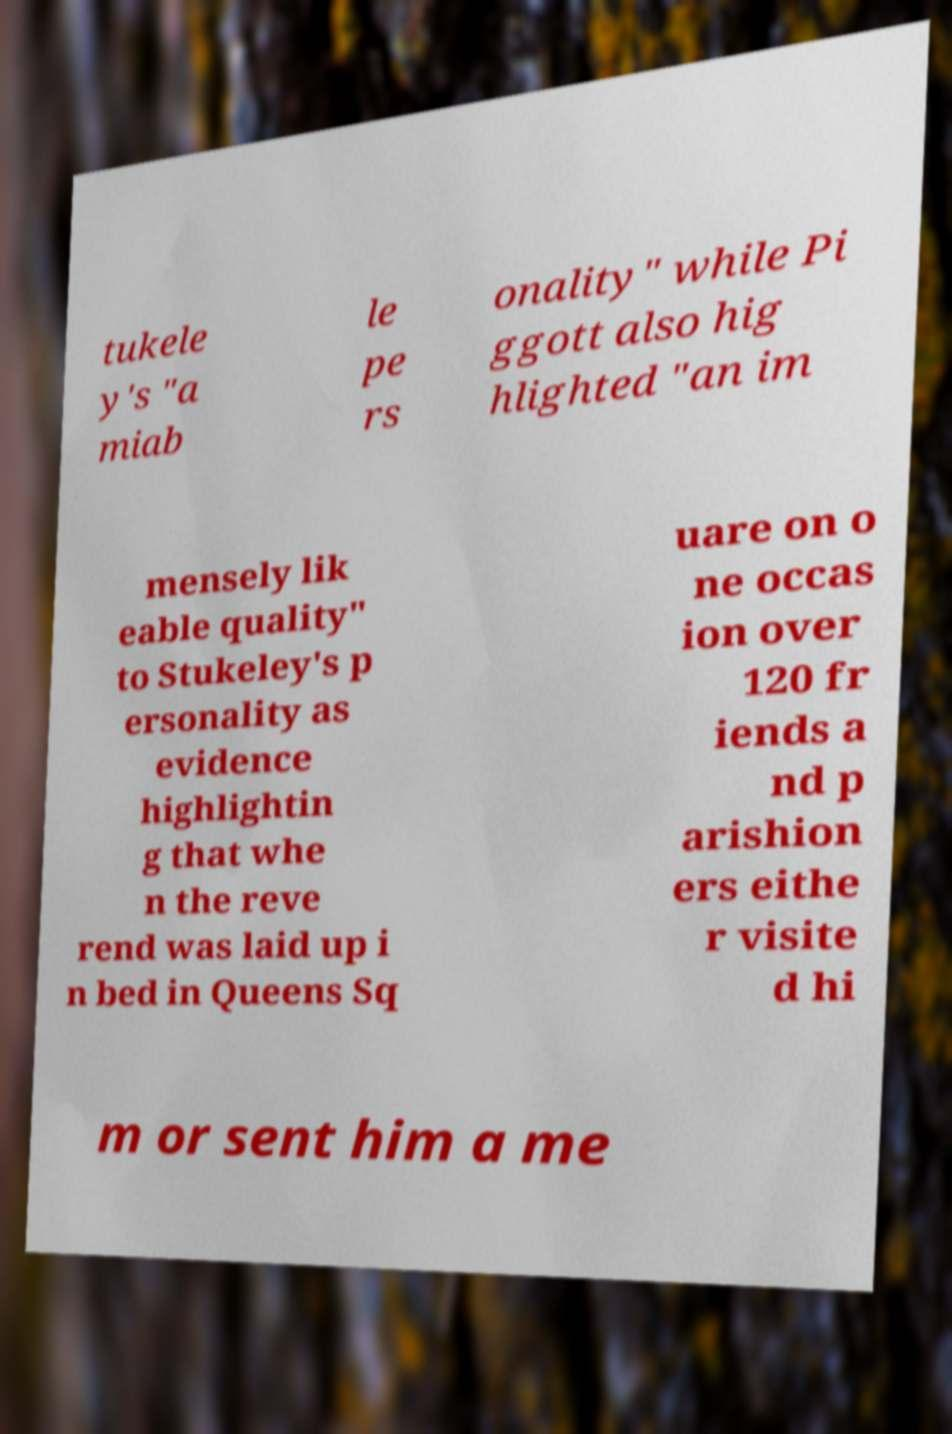Please read and relay the text visible in this image. What does it say? tukele y's "a miab le pe rs onality" while Pi ggott also hig hlighted "an im mensely lik eable quality" to Stukeley's p ersonality as evidence highlightin g that whe n the reve rend was laid up i n bed in Queens Sq uare on o ne occas ion over 120 fr iends a nd p arishion ers eithe r visite d hi m or sent him a me 